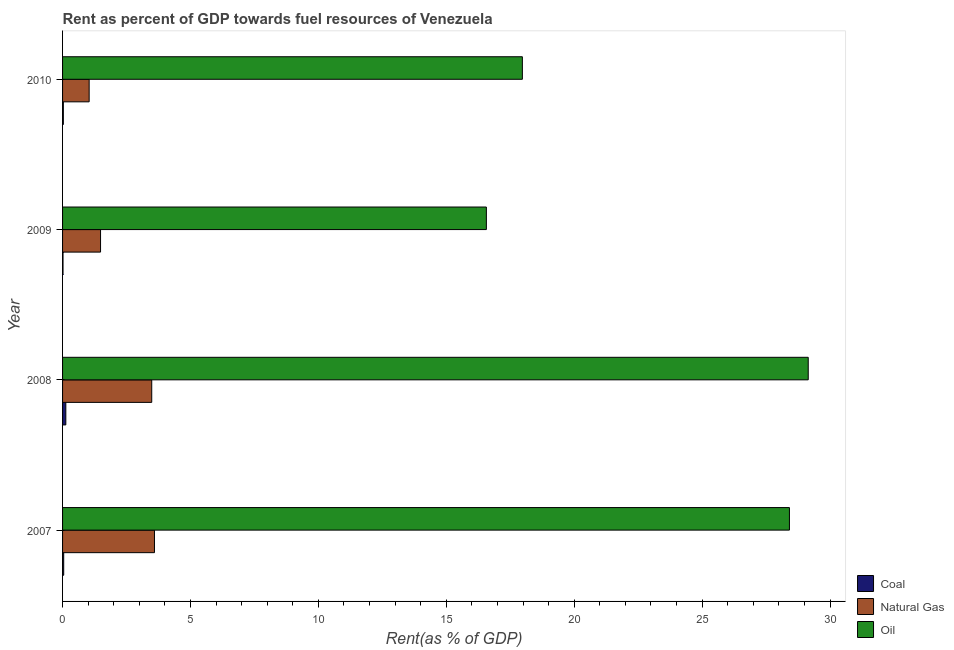Are the number of bars per tick equal to the number of legend labels?
Offer a very short reply. Yes. How many bars are there on the 3rd tick from the bottom?
Your response must be concise. 3. What is the rent towards oil in 2007?
Your response must be concise. 28.41. Across all years, what is the maximum rent towards oil?
Provide a short and direct response. 29.15. Across all years, what is the minimum rent towards natural gas?
Keep it short and to the point. 1.04. In which year was the rent towards oil minimum?
Offer a terse response. 2009. What is the total rent towards oil in the graph?
Provide a short and direct response. 92.1. What is the difference between the rent towards oil in 2007 and that in 2010?
Make the answer very short. 10.44. What is the difference between the rent towards oil in 2009 and the rent towards coal in 2010?
Provide a short and direct response. 16.53. What is the average rent towards coal per year?
Ensure brevity in your answer.  0.06. In the year 2009, what is the difference between the rent towards oil and rent towards natural gas?
Provide a succinct answer. 15.08. In how many years, is the rent towards coal greater than 19 %?
Offer a terse response. 0. What is the ratio of the rent towards oil in 2009 to that in 2010?
Your answer should be very brief. 0.92. Is the rent towards natural gas in 2009 less than that in 2010?
Provide a short and direct response. No. What is the difference between the highest and the second highest rent towards coal?
Your answer should be compact. 0.08. What is the difference between the highest and the lowest rent towards natural gas?
Offer a very short reply. 2.55. What does the 3rd bar from the top in 2009 represents?
Provide a succinct answer. Coal. What does the 2nd bar from the bottom in 2007 represents?
Offer a very short reply. Natural Gas. Is it the case that in every year, the sum of the rent towards coal and rent towards natural gas is greater than the rent towards oil?
Keep it short and to the point. No. Are all the bars in the graph horizontal?
Provide a succinct answer. Yes. How many years are there in the graph?
Give a very brief answer. 4. What is the difference between two consecutive major ticks on the X-axis?
Keep it short and to the point. 5. Are the values on the major ticks of X-axis written in scientific E-notation?
Provide a succinct answer. No. How are the legend labels stacked?
Ensure brevity in your answer.  Vertical. What is the title of the graph?
Provide a short and direct response. Rent as percent of GDP towards fuel resources of Venezuela. What is the label or title of the X-axis?
Provide a succinct answer. Rent(as % of GDP). What is the label or title of the Y-axis?
Offer a very short reply. Year. What is the Rent(as % of GDP) in Coal in 2007?
Your answer should be very brief. 0.04. What is the Rent(as % of GDP) of Natural Gas in 2007?
Provide a short and direct response. 3.59. What is the Rent(as % of GDP) in Oil in 2007?
Make the answer very short. 28.41. What is the Rent(as % of GDP) in Coal in 2008?
Provide a succinct answer. 0.13. What is the Rent(as % of GDP) in Natural Gas in 2008?
Your answer should be very brief. 3.49. What is the Rent(as % of GDP) of Oil in 2008?
Provide a succinct answer. 29.15. What is the Rent(as % of GDP) in Coal in 2009?
Provide a succinct answer. 0.02. What is the Rent(as % of GDP) in Natural Gas in 2009?
Ensure brevity in your answer.  1.48. What is the Rent(as % of GDP) of Oil in 2009?
Give a very brief answer. 16.57. What is the Rent(as % of GDP) of Coal in 2010?
Your answer should be very brief. 0.03. What is the Rent(as % of GDP) in Natural Gas in 2010?
Your response must be concise. 1.04. What is the Rent(as % of GDP) in Oil in 2010?
Your answer should be very brief. 17.97. Across all years, what is the maximum Rent(as % of GDP) in Coal?
Provide a short and direct response. 0.13. Across all years, what is the maximum Rent(as % of GDP) in Natural Gas?
Ensure brevity in your answer.  3.59. Across all years, what is the maximum Rent(as % of GDP) of Oil?
Ensure brevity in your answer.  29.15. Across all years, what is the minimum Rent(as % of GDP) in Coal?
Ensure brevity in your answer.  0.02. Across all years, what is the minimum Rent(as % of GDP) of Natural Gas?
Give a very brief answer. 1.04. Across all years, what is the minimum Rent(as % of GDP) of Oil?
Offer a terse response. 16.57. What is the total Rent(as % of GDP) in Coal in the graph?
Your response must be concise. 0.22. What is the total Rent(as % of GDP) in Natural Gas in the graph?
Your answer should be very brief. 9.6. What is the total Rent(as % of GDP) of Oil in the graph?
Your answer should be compact. 92.1. What is the difference between the Rent(as % of GDP) in Coal in 2007 and that in 2008?
Provide a succinct answer. -0.08. What is the difference between the Rent(as % of GDP) of Natural Gas in 2007 and that in 2008?
Provide a succinct answer. 0.11. What is the difference between the Rent(as % of GDP) in Oil in 2007 and that in 2008?
Your response must be concise. -0.74. What is the difference between the Rent(as % of GDP) in Coal in 2007 and that in 2009?
Offer a very short reply. 0.03. What is the difference between the Rent(as % of GDP) of Natural Gas in 2007 and that in 2009?
Offer a terse response. 2.11. What is the difference between the Rent(as % of GDP) of Oil in 2007 and that in 2009?
Make the answer very short. 11.85. What is the difference between the Rent(as % of GDP) in Coal in 2007 and that in 2010?
Provide a succinct answer. 0.01. What is the difference between the Rent(as % of GDP) in Natural Gas in 2007 and that in 2010?
Keep it short and to the point. 2.55. What is the difference between the Rent(as % of GDP) of Oil in 2007 and that in 2010?
Keep it short and to the point. 10.44. What is the difference between the Rent(as % of GDP) of Coal in 2008 and that in 2009?
Provide a succinct answer. 0.11. What is the difference between the Rent(as % of GDP) in Natural Gas in 2008 and that in 2009?
Offer a terse response. 2. What is the difference between the Rent(as % of GDP) in Oil in 2008 and that in 2009?
Provide a succinct answer. 12.58. What is the difference between the Rent(as % of GDP) of Coal in 2008 and that in 2010?
Keep it short and to the point. 0.1. What is the difference between the Rent(as % of GDP) of Natural Gas in 2008 and that in 2010?
Your answer should be very brief. 2.45. What is the difference between the Rent(as % of GDP) in Oil in 2008 and that in 2010?
Give a very brief answer. 11.17. What is the difference between the Rent(as % of GDP) of Coal in 2009 and that in 2010?
Your answer should be compact. -0.01. What is the difference between the Rent(as % of GDP) of Natural Gas in 2009 and that in 2010?
Keep it short and to the point. 0.45. What is the difference between the Rent(as % of GDP) in Oil in 2009 and that in 2010?
Offer a very short reply. -1.41. What is the difference between the Rent(as % of GDP) in Coal in 2007 and the Rent(as % of GDP) in Natural Gas in 2008?
Make the answer very short. -3.44. What is the difference between the Rent(as % of GDP) of Coal in 2007 and the Rent(as % of GDP) of Oil in 2008?
Give a very brief answer. -29.1. What is the difference between the Rent(as % of GDP) of Natural Gas in 2007 and the Rent(as % of GDP) of Oil in 2008?
Keep it short and to the point. -25.55. What is the difference between the Rent(as % of GDP) of Coal in 2007 and the Rent(as % of GDP) of Natural Gas in 2009?
Keep it short and to the point. -1.44. What is the difference between the Rent(as % of GDP) of Coal in 2007 and the Rent(as % of GDP) of Oil in 2009?
Your answer should be very brief. -16.52. What is the difference between the Rent(as % of GDP) in Natural Gas in 2007 and the Rent(as % of GDP) in Oil in 2009?
Provide a short and direct response. -12.97. What is the difference between the Rent(as % of GDP) in Coal in 2007 and the Rent(as % of GDP) in Natural Gas in 2010?
Your answer should be compact. -0.99. What is the difference between the Rent(as % of GDP) of Coal in 2007 and the Rent(as % of GDP) of Oil in 2010?
Provide a succinct answer. -17.93. What is the difference between the Rent(as % of GDP) in Natural Gas in 2007 and the Rent(as % of GDP) in Oil in 2010?
Provide a succinct answer. -14.38. What is the difference between the Rent(as % of GDP) in Coal in 2008 and the Rent(as % of GDP) in Natural Gas in 2009?
Your answer should be compact. -1.36. What is the difference between the Rent(as % of GDP) of Coal in 2008 and the Rent(as % of GDP) of Oil in 2009?
Offer a very short reply. -16.44. What is the difference between the Rent(as % of GDP) in Natural Gas in 2008 and the Rent(as % of GDP) in Oil in 2009?
Give a very brief answer. -13.08. What is the difference between the Rent(as % of GDP) of Coal in 2008 and the Rent(as % of GDP) of Natural Gas in 2010?
Offer a terse response. -0.91. What is the difference between the Rent(as % of GDP) in Coal in 2008 and the Rent(as % of GDP) in Oil in 2010?
Keep it short and to the point. -17.85. What is the difference between the Rent(as % of GDP) in Natural Gas in 2008 and the Rent(as % of GDP) in Oil in 2010?
Provide a short and direct response. -14.49. What is the difference between the Rent(as % of GDP) of Coal in 2009 and the Rent(as % of GDP) of Natural Gas in 2010?
Offer a terse response. -1.02. What is the difference between the Rent(as % of GDP) of Coal in 2009 and the Rent(as % of GDP) of Oil in 2010?
Make the answer very short. -17.95. What is the difference between the Rent(as % of GDP) in Natural Gas in 2009 and the Rent(as % of GDP) in Oil in 2010?
Provide a succinct answer. -16.49. What is the average Rent(as % of GDP) in Coal per year?
Ensure brevity in your answer.  0.05. What is the average Rent(as % of GDP) of Natural Gas per year?
Provide a succinct answer. 2.4. What is the average Rent(as % of GDP) of Oil per year?
Offer a terse response. 23.02. In the year 2007, what is the difference between the Rent(as % of GDP) of Coal and Rent(as % of GDP) of Natural Gas?
Ensure brevity in your answer.  -3.55. In the year 2007, what is the difference between the Rent(as % of GDP) of Coal and Rent(as % of GDP) of Oil?
Give a very brief answer. -28.37. In the year 2007, what is the difference between the Rent(as % of GDP) of Natural Gas and Rent(as % of GDP) of Oil?
Ensure brevity in your answer.  -24.82. In the year 2008, what is the difference between the Rent(as % of GDP) in Coal and Rent(as % of GDP) in Natural Gas?
Your answer should be compact. -3.36. In the year 2008, what is the difference between the Rent(as % of GDP) of Coal and Rent(as % of GDP) of Oil?
Your response must be concise. -29.02. In the year 2008, what is the difference between the Rent(as % of GDP) of Natural Gas and Rent(as % of GDP) of Oil?
Keep it short and to the point. -25.66. In the year 2009, what is the difference between the Rent(as % of GDP) of Coal and Rent(as % of GDP) of Natural Gas?
Ensure brevity in your answer.  -1.47. In the year 2009, what is the difference between the Rent(as % of GDP) in Coal and Rent(as % of GDP) in Oil?
Your answer should be compact. -16.55. In the year 2009, what is the difference between the Rent(as % of GDP) in Natural Gas and Rent(as % of GDP) in Oil?
Give a very brief answer. -15.08. In the year 2010, what is the difference between the Rent(as % of GDP) of Coal and Rent(as % of GDP) of Natural Gas?
Make the answer very short. -1.01. In the year 2010, what is the difference between the Rent(as % of GDP) in Coal and Rent(as % of GDP) in Oil?
Your response must be concise. -17.94. In the year 2010, what is the difference between the Rent(as % of GDP) of Natural Gas and Rent(as % of GDP) of Oil?
Offer a very short reply. -16.93. What is the ratio of the Rent(as % of GDP) in Coal in 2007 to that in 2008?
Your response must be concise. 0.35. What is the ratio of the Rent(as % of GDP) in Natural Gas in 2007 to that in 2008?
Keep it short and to the point. 1.03. What is the ratio of the Rent(as % of GDP) in Oil in 2007 to that in 2008?
Keep it short and to the point. 0.97. What is the ratio of the Rent(as % of GDP) of Coal in 2007 to that in 2009?
Ensure brevity in your answer.  2.52. What is the ratio of the Rent(as % of GDP) of Natural Gas in 2007 to that in 2009?
Make the answer very short. 2.42. What is the ratio of the Rent(as % of GDP) of Oil in 2007 to that in 2009?
Make the answer very short. 1.72. What is the ratio of the Rent(as % of GDP) in Coal in 2007 to that in 2010?
Your answer should be compact. 1.46. What is the ratio of the Rent(as % of GDP) of Natural Gas in 2007 to that in 2010?
Make the answer very short. 3.46. What is the ratio of the Rent(as % of GDP) in Oil in 2007 to that in 2010?
Give a very brief answer. 1.58. What is the ratio of the Rent(as % of GDP) of Coal in 2008 to that in 2009?
Offer a very short reply. 7.22. What is the ratio of the Rent(as % of GDP) in Natural Gas in 2008 to that in 2009?
Provide a succinct answer. 2.35. What is the ratio of the Rent(as % of GDP) in Oil in 2008 to that in 2009?
Provide a short and direct response. 1.76. What is the ratio of the Rent(as % of GDP) in Coal in 2008 to that in 2010?
Ensure brevity in your answer.  4.18. What is the ratio of the Rent(as % of GDP) of Natural Gas in 2008 to that in 2010?
Your answer should be compact. 3.35. What is the ratio of the Rent(as % of GDP) in Oil in 2008 to that in 2010?
Offer a terse response. 1.62. What is the ratio of the Rent(as % of GDP) of Coal in 2009 to that in 2010?
Your answer should be very brief. 0.58. What is the ratio of the Rent(as % of GDP) in Natural Gas in 2009 to that in 2010?
Keep it short and to the point. 1.43. What is the ratio of the Rent(as % of GDP) in Oil in 2009 to that in 2010?
Provide a short and direct response. 0.92. What is the difference between the highest and the second highest Rent(as % of GDP) in Coal?
Your response must be concise. 0.08. What is the difference between the highest and the second highest Rent(as % of GDP) in Natural Gas?
Make the answer very short. 0.11. What is the difference between the highest and the second highest Rent(as % of GDP) in Oil?
Provide a short and direct response. 0.74. What is the difference between the highest and the lowest Rent(as % of GDP) of Coal?
Give a very brief answer. 0.11. What is the difference between the highest and the lowest Rent(as % of GDP) in Natural Gas?
Offer a very short reply. 2.55. What is the difference between the highest and the lowest Rent(as % of GDP) in Oil?
Keep it short and to the point. 12.58. 